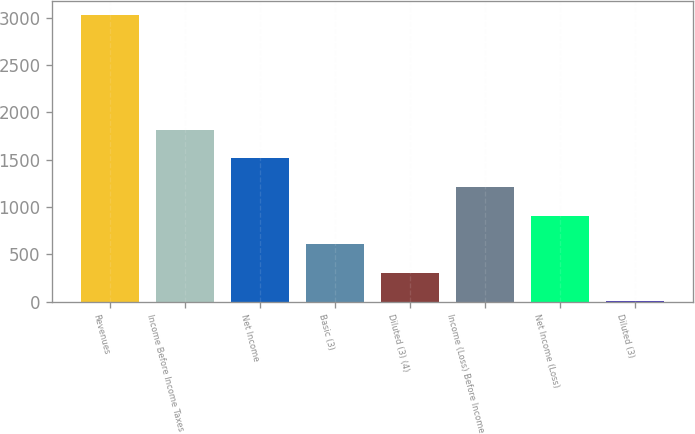Convert chart to OTSL. <chart><loc_0><loc_0><loc_500><loc_500><bar_chart><fcel>Revenues<fcel>Income Before Income Taxes<fcel>Net Income<fcel>Basic (3)<fcel>Diluted (3) (4)<fcel>Income (Loss) Before Income<fcel>Net Income (Loss)<fcel>Diluted (3)<nl><fcel>3022<fcel>1813.49<fcel>1511.37<fcel>605<fcel>302.88<fcel>1209.24<fcel>907.12<fcel>0.75<nl></chart> 